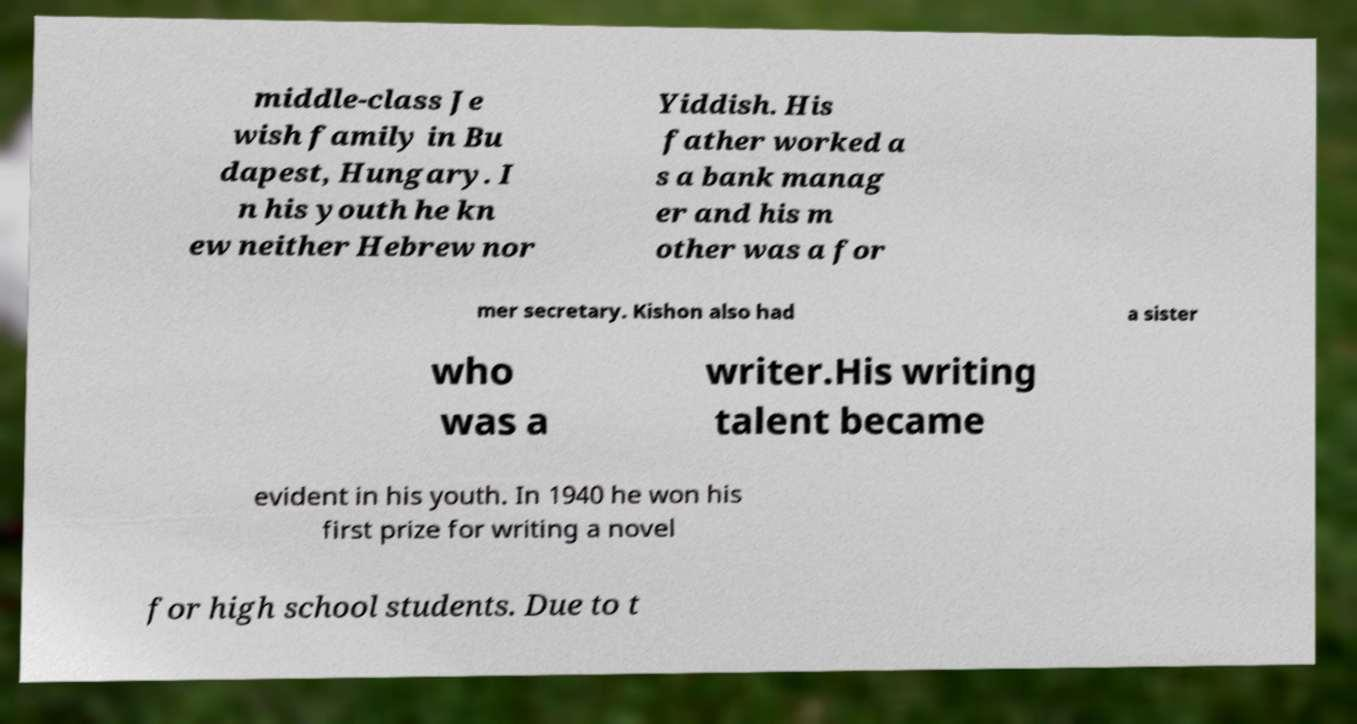Could you extract and type out the text from this image? middle-class Je wish family in Bu dapest, Hungary. I n his youth he kn ew neither Hebrew nor Yiddish. His father worked a s a bank manag er and his m other was a for mer secretary. Kishon also had a sister who was a writer.His writing talent became evident in his youth. In 1940 he won his first prize for writing a novel for high school students. Due to t 